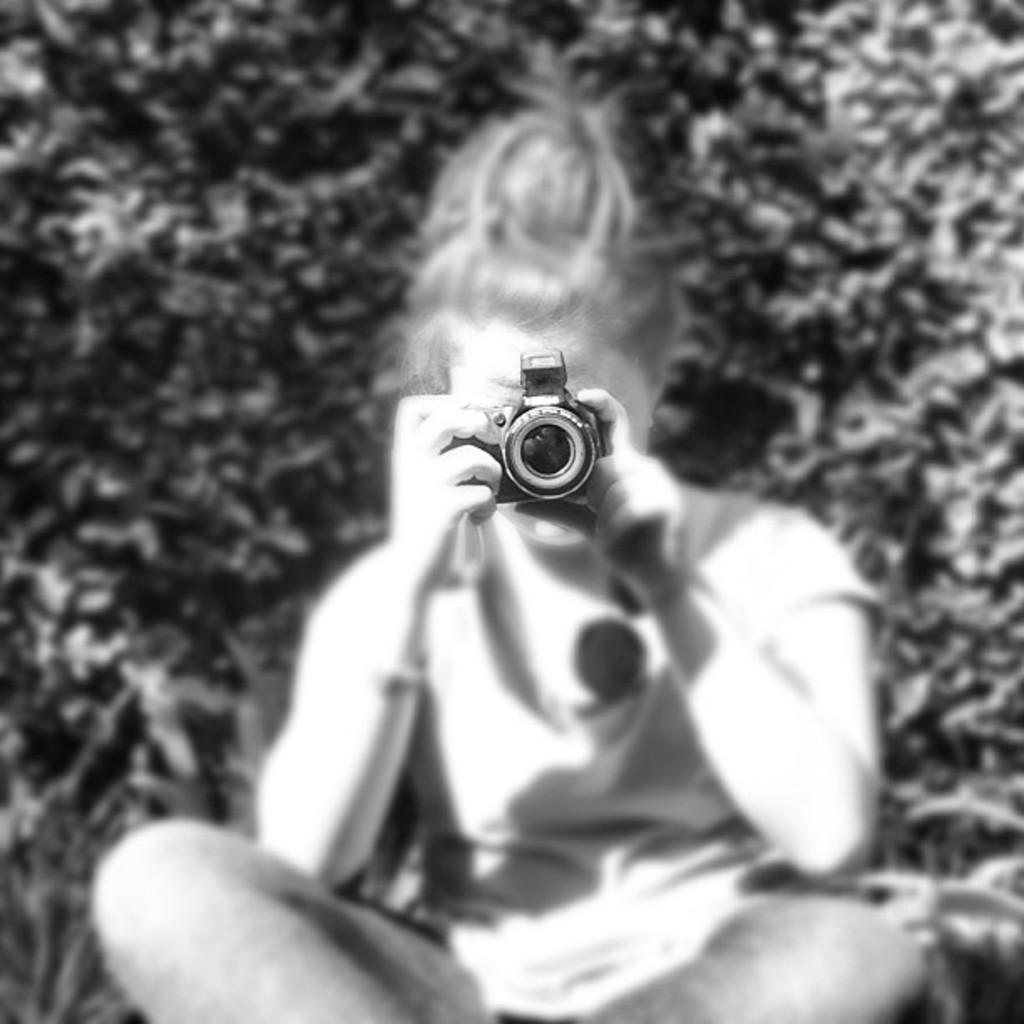Could you give a brief overview of what you see in this image? It is a black and white picture a kid is sitting and she is holding a camera and capturing something with it,in the background there are some trees. 